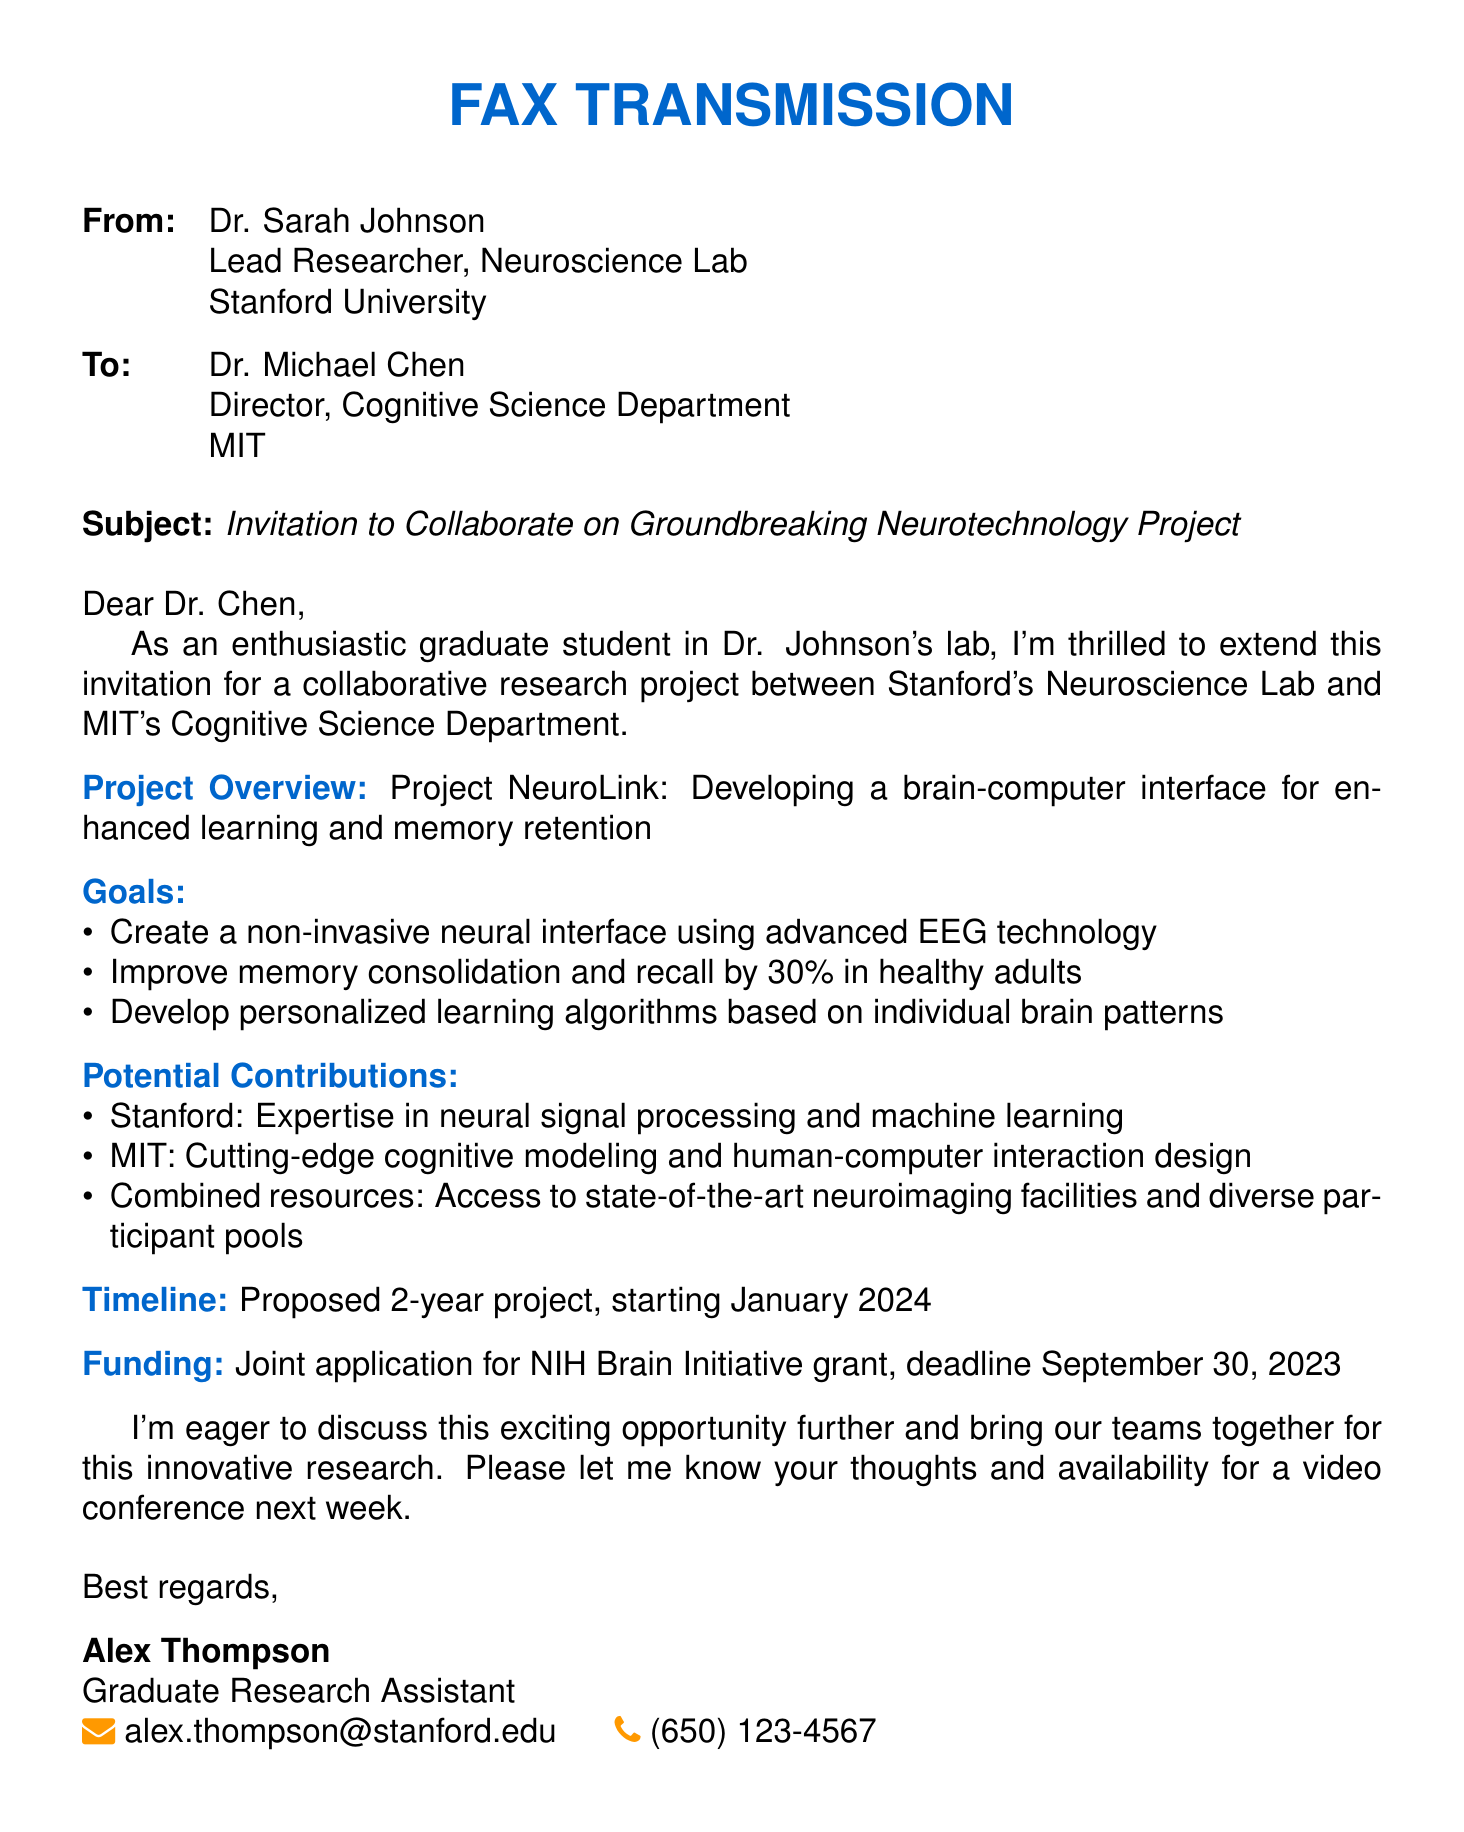What is the project title? The project title is the name given to the collaborative research initiative, which is stated in the document.
Answer: Project NeuroLink Who is the sender of the fax? The sender's information is provided at the beginning of the document, including their name and position.
Answer: Dr. Sarah Johnson What is the proposed start date of the project? The proposed start date is mentioned clearly in the document under the timeline section.
Answer: January 2024 What percentage improvement in memory recall is targeted by the project? The targeted improvement percentage is specified in the goals section of the document.
Answer: 30% Which institutions are involved in this collaboration? The involved institutions are provided in the introductory lines of the document.
Answer: Stanford University's Neuroscience Lab and MIT's Cognitive Science Department What is the deadline for the funding application? The deadline for the funding application is specified in the funding section of the document.
Answer: September 30, 2023 What type of funding is being sought for the project? The type of funding is indicated in the funding section, specifying the agency or program being applied to.
Answer: NIH Brain Initiative grant What are the two main areas of expertise mentioned for Stanford and MIT? The areas of expertise are listed in the potential contributions section of the document, representing both institutions' strengths.
Answer: Neural signal processing and cognitive modeling Who is the recipient of the fax? The recipient's name and title are listed at the beginning of the document.
Answer: Dr. Michael Chen 